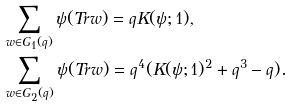Convert formula to latex. <formula><loc_0><loc_0><loc_500><loc_500>& \sum _ { w \in G _ { 1 } ( q ) } \psi ( T r w ) = q K ( \psi ; 1 ) , \\ & \sum _ { w \in G _ { 2 } ( q ) } \psi ( T r w ) = q ^ { 4 } ( K ( \psi ; 1 ) ^ { 2 } + q ^ { 3 } - q ) .</formula> 